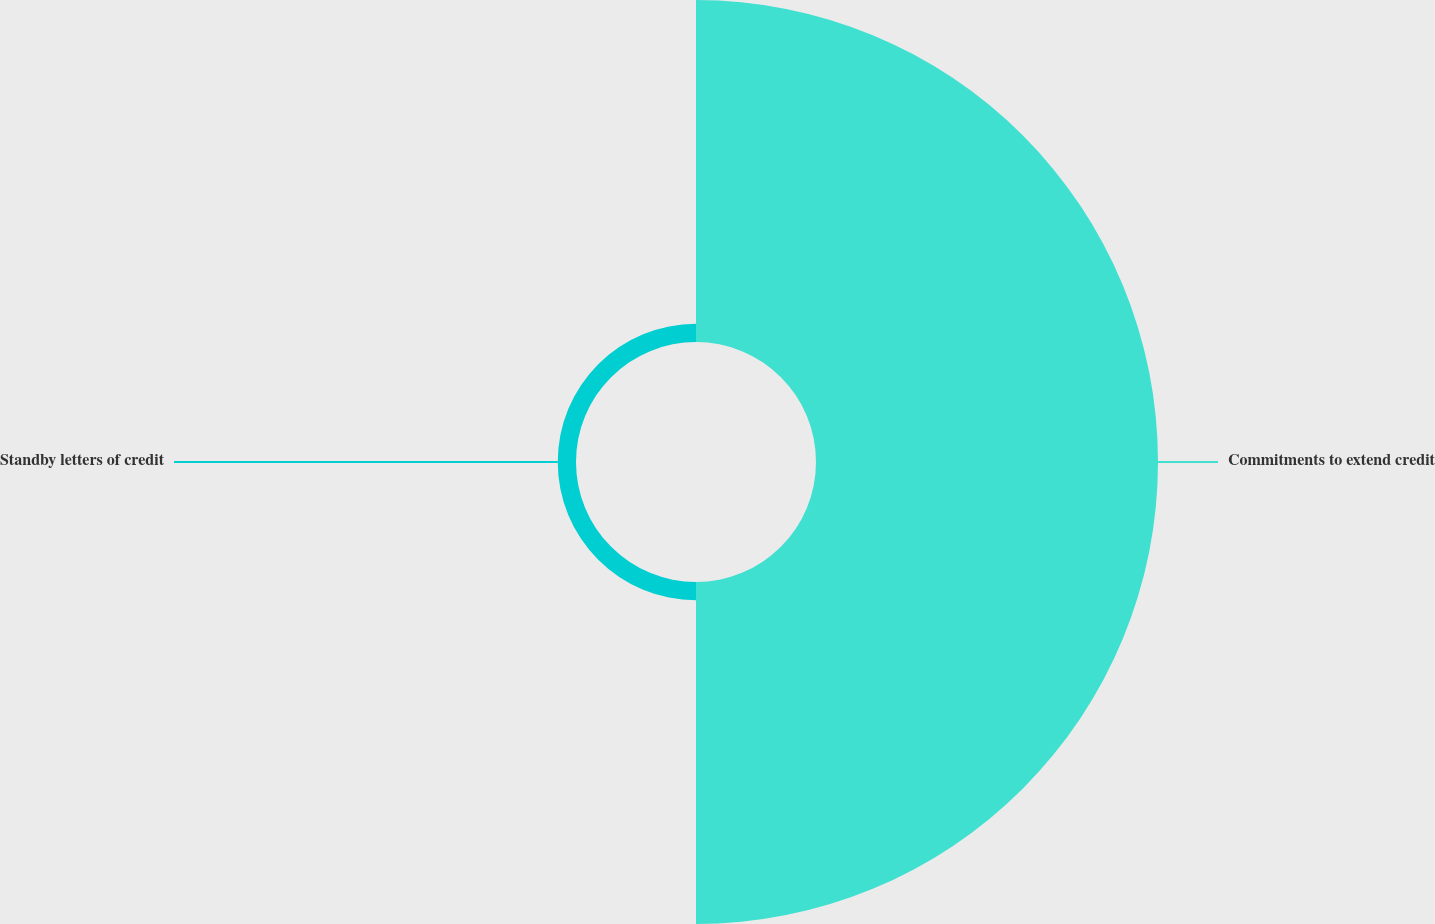Convert chart to OTSL. <chart><loc_0><loc_0><loc_500><loc_500><pie_chart><fcel>Commitments to extend credit<fcel>Standby letters of credit<nl><fcel>94.93%<fcel>5.07%<nl></chart> 